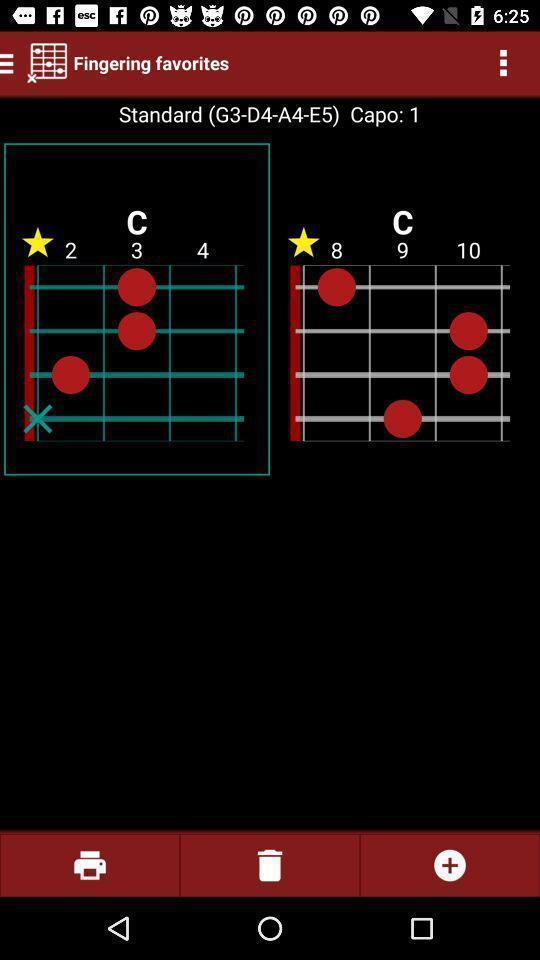Describe the visual elements of this screenshot. Screen shows multiple options in a music application. 